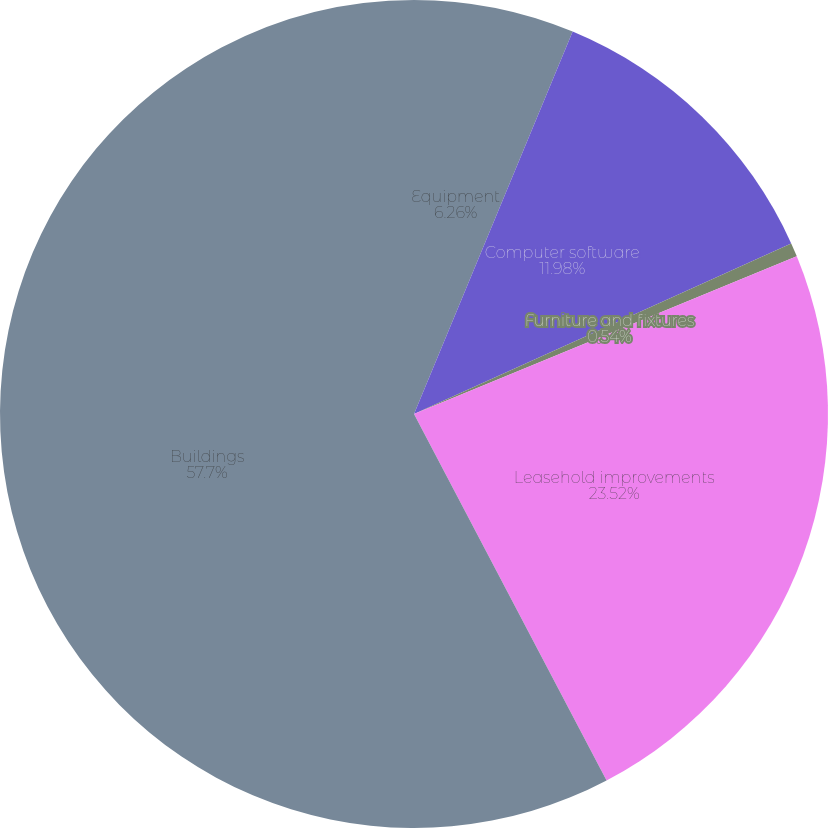Convert chart. <chart><loc_0><loc_0><loc_500><loc_500><pie_chart><fcel>Equipment<fcel>Computer software<fcel>Furniture and fixtures<fcel>Leasehold improvements<fcel>Buildings<nl><fcel>6.26%<fcel>11.98%<fcel>0.54%<fcel>23.52%<fcel>57.7%<nl></chart> 